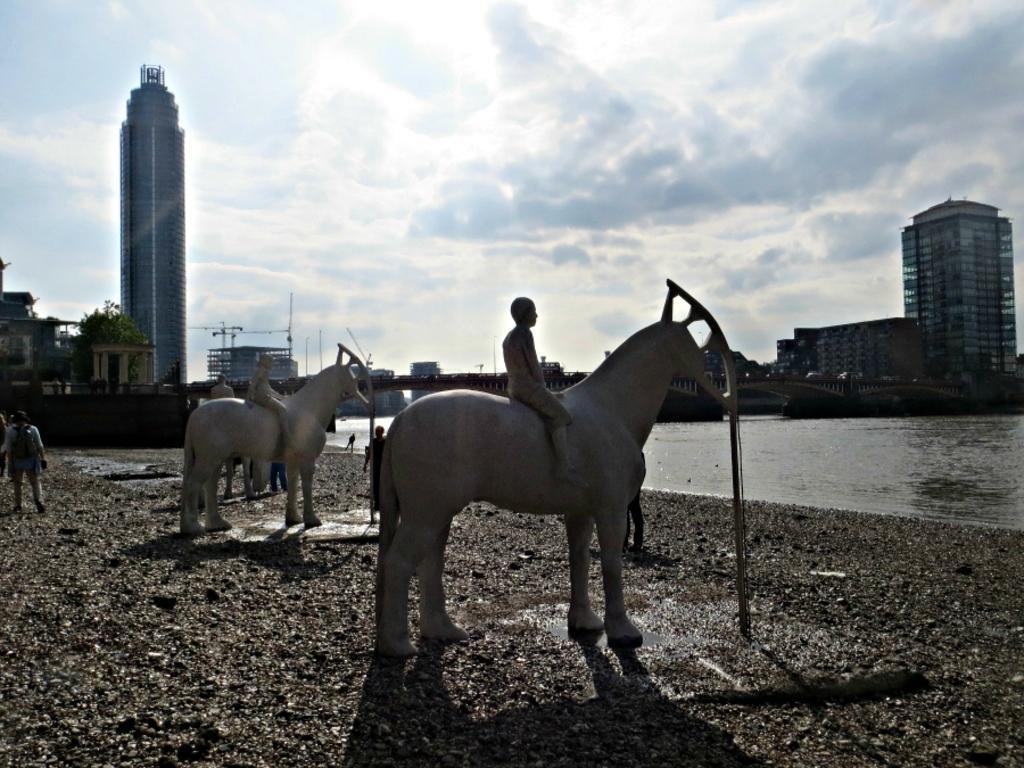In one or two sentences, can you explain what this image depicts? In this picture we can see statues of two people are sitting on horses on the ground and in the background we can see few people, water, buildings, trees and the sky. 